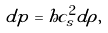Convert formula to latex. <formula><loc_0><loc_0><loc_500><loc_500>d p = h c _ { s } ^ { 2 } d \rho ,</formula> 